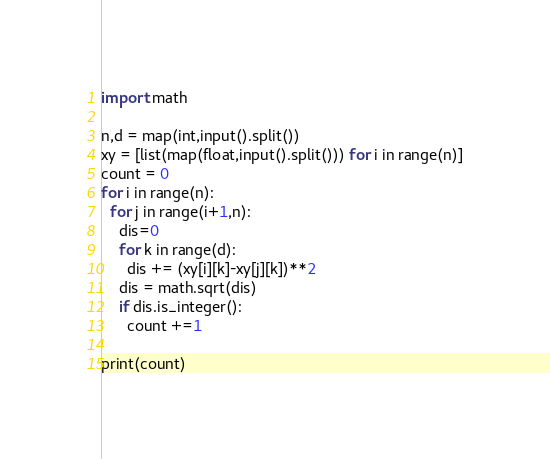<code> <loc_0><loc_0><loc_500><loc_500><_Python_>import math

n,d = map(int,input().split())
xy = [list(map(float,input().split())) for i in range(n)]
count = 0
for i in range(n):
  for j in range(i+1,n):
    dis=0
    for k in range(d):
      dis += (xy[i][k]-xy[j][k])**2
    dis = math.sqrt(dis)
    if dis.is_integer():
      count +=1
      
print(count)</code> 